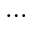Convert formula to latex. <formula><loc_0><loc_0><loc_500><loc_500>\dots</formula> 